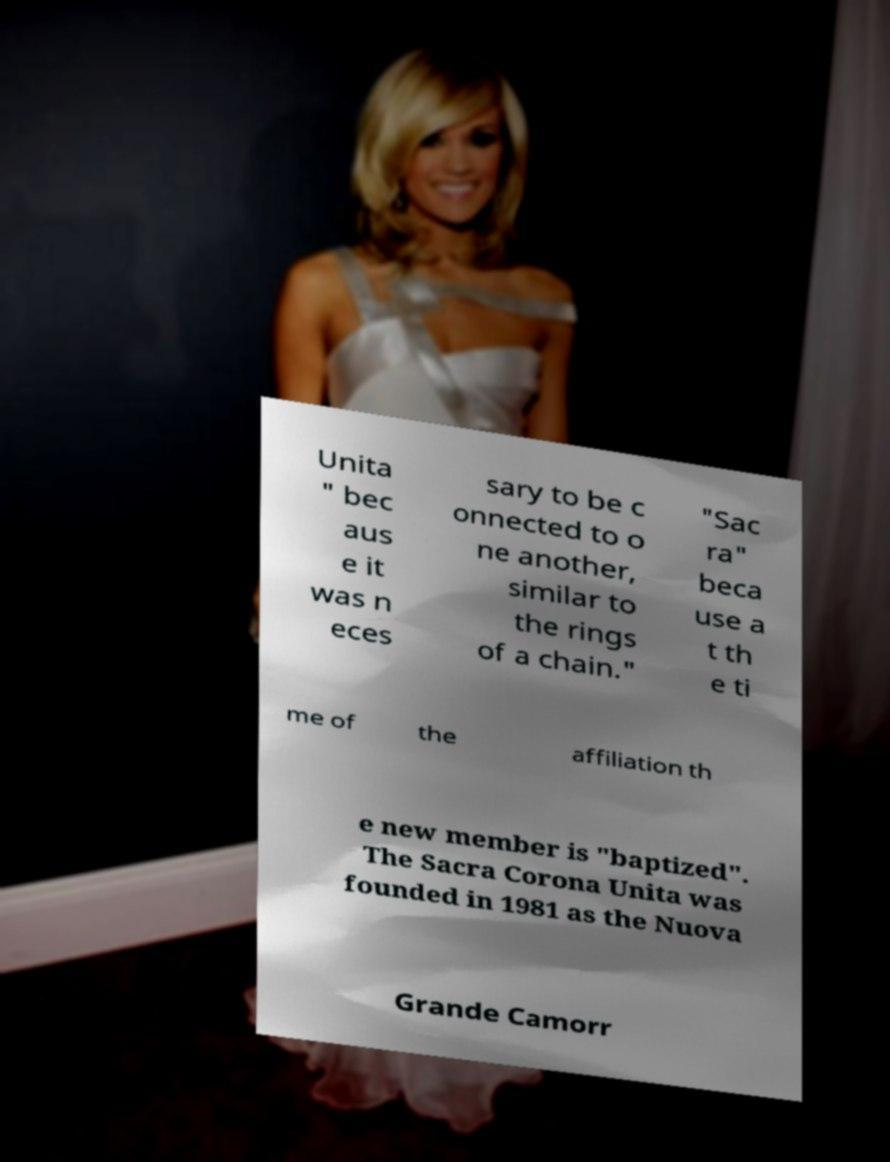Could you extract and type out the text from this image? Unita " bec aus e it was n eces sary to be c onnected to o ne another, similar to the rings of a chain." "Sac ra" beca use a t th e ti me of the affiliation th e new member is "baptized". The Sacra Corona Unita was founded in 1981 as the Nuova Grande Camorr 